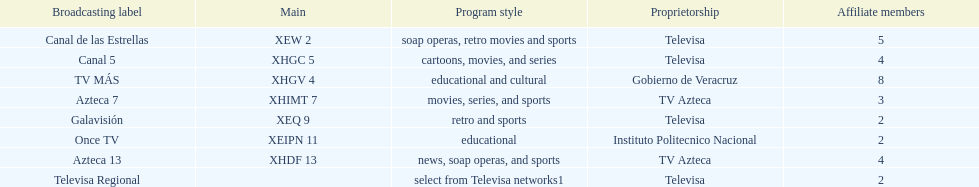Who has the most number of affiliates? TV MÁS. 